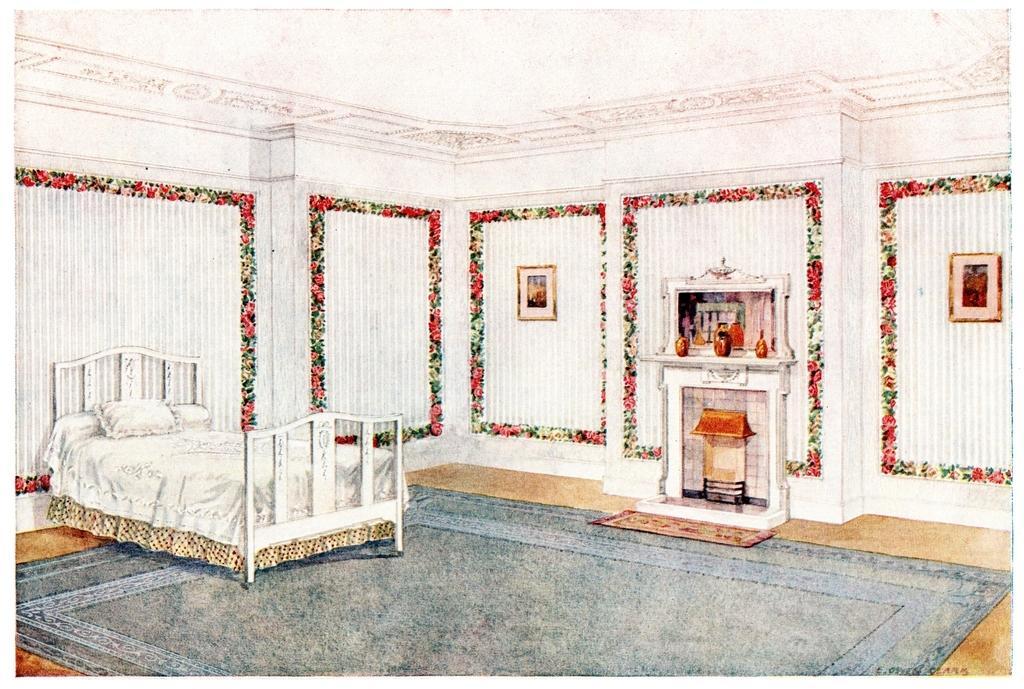Please provide a concise description of this image. In this image we can see the painting of a bed with pillows and there is a carpet on the floor, there is a decoration on the wall and there are a few frames are hanging and there is a fireplace, above that there are a few objects, in front of that there is a mat. At the top of the image there is a ceiling. 